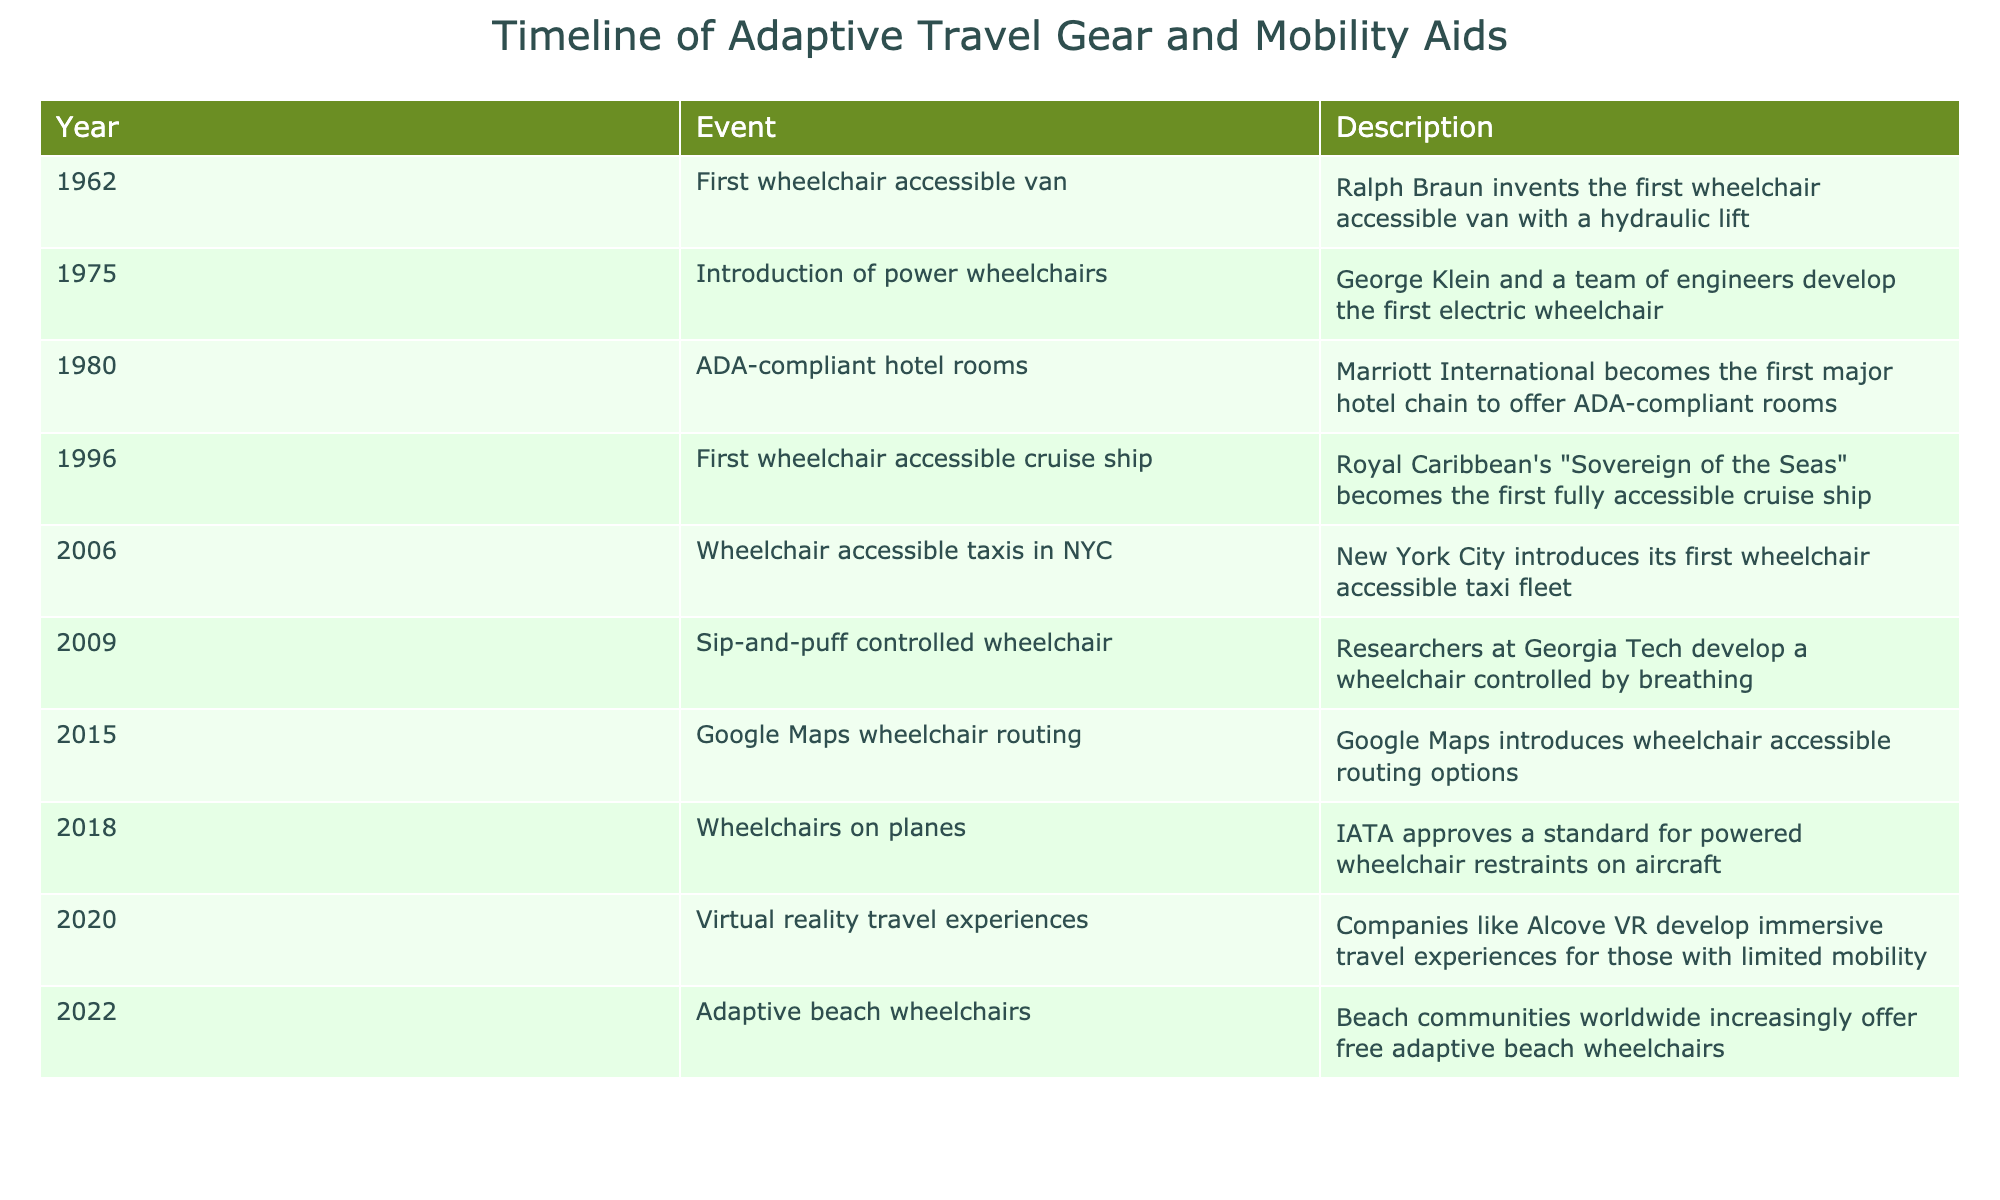What year was the first wheelchair accessible van introduced? The table lists the event "First wheelchair accessible van" in the year 1962, indicating that this was the year it was introduced.
Answer: 1962 What event took place in 2015? Looking at the table, the entry for the year 2015 shows "Google Maps wheelchair routing," which was the event that took place that year.
Answer: Google Maps wheelchair routing Which company became the first to offer ADA-compliant hotel rooms? The table specifies that Marriott International was the first major hotel chain to offer ADA-compliant hotel rooms in 1980.
Answer: Marriott International How many events listed are from the 2000s? The table includes events from 2000 to 2009: "Wheelchair accessible taxis in NYC" (2006), "Sip-and-puff controlled wheelchair" (2009), totaling 2 events.
Answer: 2 Was the first wheelchair accessible cruise ship launched before 2000? The first wheelchair accessible cruise ship, "Sovereign of the Seas," is noted as being launched in 1996, which is before the year 2000, making the statement true.
Answer: Yes What year saw the introduction of the sip-and-puff controlled wheelchair? The sip-and-puff controlled wheelchair was introduced in 2009, as per the event descriptor in the table.
Answer: 2009 How many years are there between the introduction of power wheelchairs and the first wheelchair accessible taxi fleet in NYC? Power wheelchairs were introduced in 1975, and wheelchair accessible taxis in NYC were introduced in 2006. The difference between these years is 2006 - 1975 = 31 years.
Answer: 31 years What was the first event regarding mobility aids on planes? The first event regarding mobility aids on planes in the table is listed as "Wheelchairs on planes," which took place in 2018.
Answer: Wheelchairs on planes Is the introduction of virtual reality travel experiences the most recent event recorded in the table? The event for virtual reality travel experiences is recorded in 2020, making it more recent than all other events listed, confirming that it is indeed the most recent.
Answer: Yes 